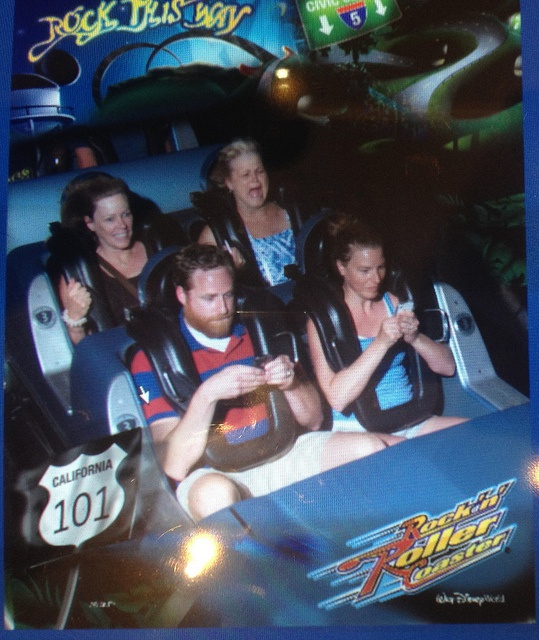Describe the objects in this image and their specific colors. I can see people in navy, lightgray, gray, brown, and darkgray tones, people in navy, black, darkgray, lightpink, and gray tones, people in navy, black, gray, and darkgray tones, people in navy, black, gray, and lightblue tones, and cell phone in navy, darkgray, lightblue, and pink tones in this image. 